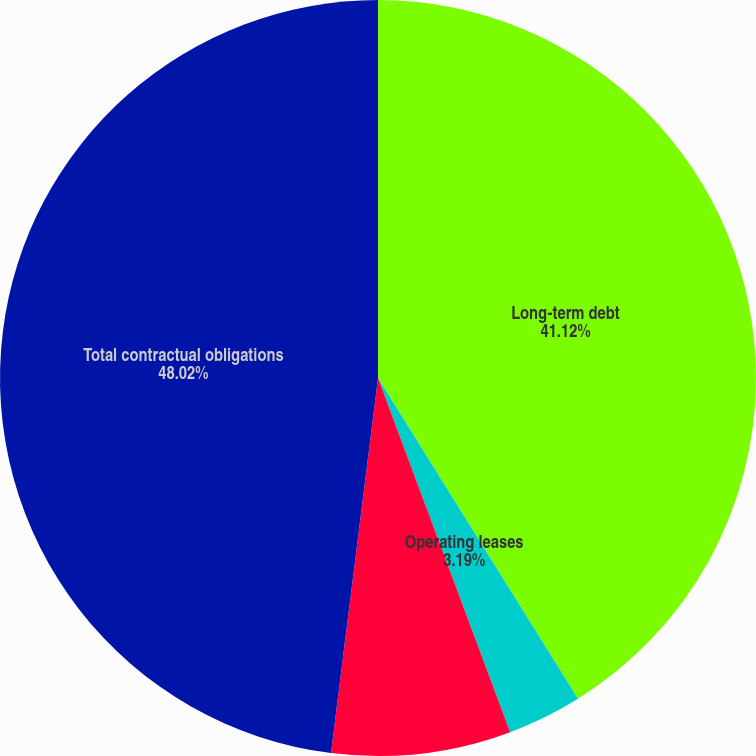Convert chart. <chart><loc_0><loc_0><loc_500><loc_500><pie_chart><fcel>Long-term debt<fcel>Operating leases<fcel>Unconditional purchase<fcel>Total contractual obligations<nl><fcel>41.12%<fcel>3.19%<fcel>7.67%<fcel>48.01%<nl></chart> 